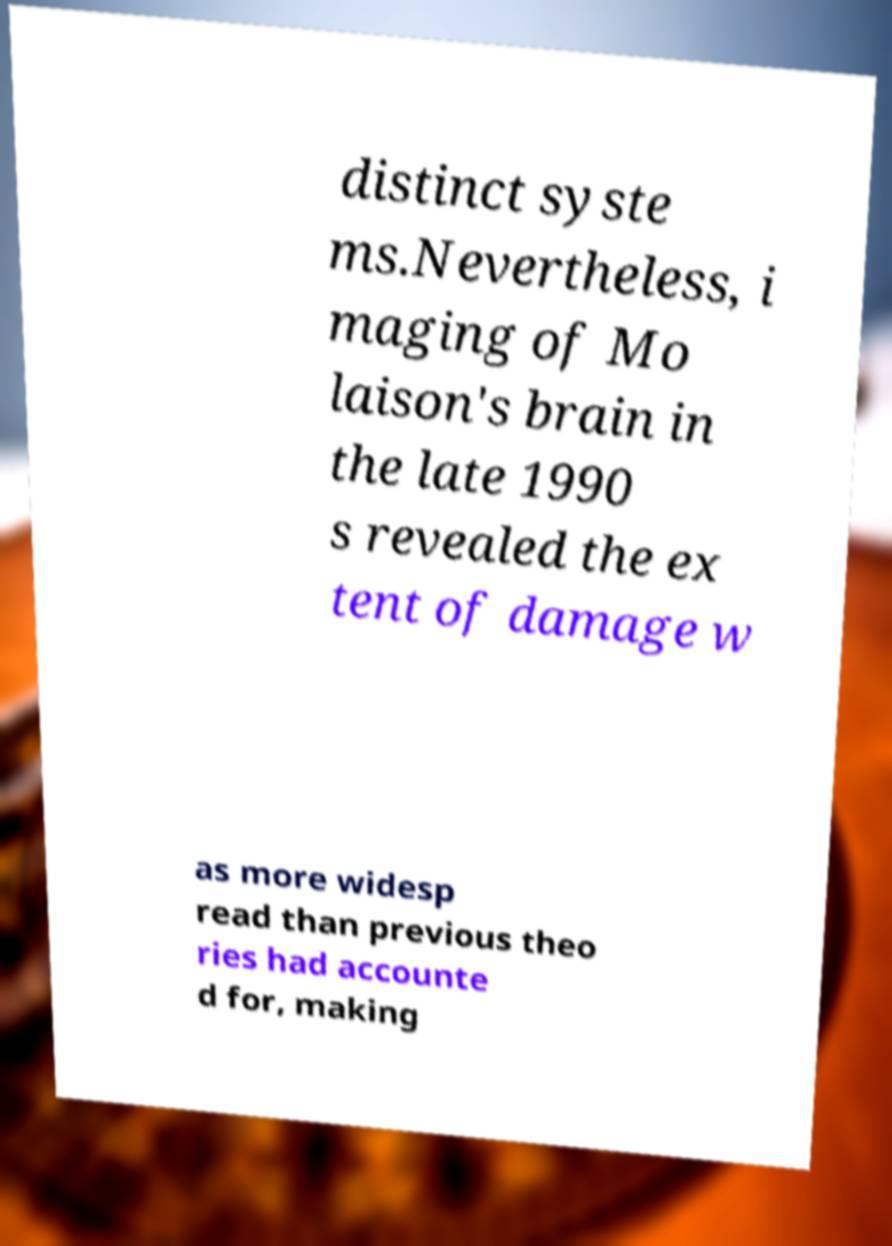Please identify and transcribe the text found in this image. distinct syste ms.Nevertheless, i maging of Mo laison's brain in the late 1990 s revealed the ex tent of damage w as more widesp read than previous theo ries had accounte d for, making 